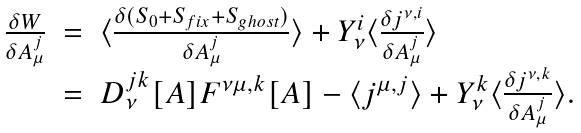Convert formula to latex. <formula><loc_0><loc_0><loc_500><loc_500>\begin{array} { l l l } \frac { \delta W } { \delta A _ { \mu } ^ { j } } & = & \langle \frac { \delta ( S _ { 0 } + S _ { f i x } + S _ { g h o s t } ) } { \delta A _ { \mu } ^ { j } } \rangle + Y _ { \nu } ^ { i } \langle \frac { \delta j ^ { \nu , i } } { \delta A _ { \mu } ^ { j } } \rangle \\ & = & D _ { \nu } ^ { j k } [ A ] F ^ { \nu \mu , k } [ A ] - \langle j ^ { \mu , j } \rangle + Y _ { \nu } ^ { k } \langle \frac { \delta j ^ { \nu , k } } { \delta A _ { \mu } ^ { j } } \rangle . \end{array}</formula> 